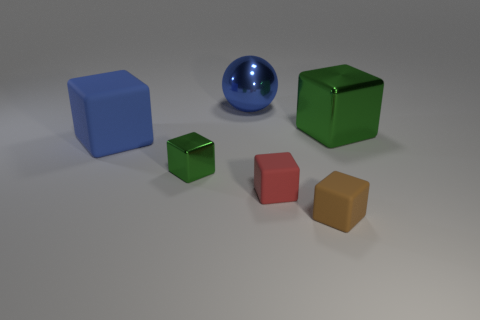Subtract all brown rubber blocks. How many blocks are left? 4 Subtract all red cubes. How many cubes are left? 4 Subtract all yellow blocks. Subtract all purple cylinders. How many blocks are left? 5 Add 1 tiny green cylinders. How many objects exist? 7 Subtract all cubes. How many objects are left? 1 Add 3 brown rubber objects. How many brown rubber objects exist? 4 Subtract 0 green cylinders. How many objects are left? 6 Subtract all red rubber things. Subtract all small red rubber cubes. How many objects are left? 4 Add 6 green metallic objects. How many green metallic objects are left? 8 